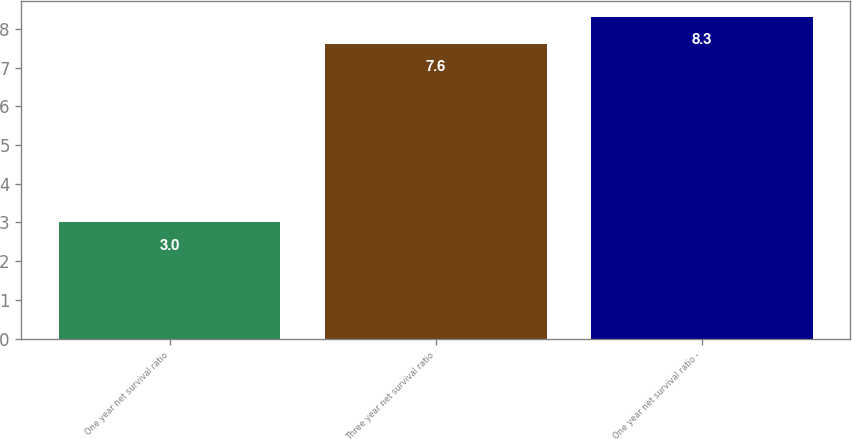Convert chart. <chart><loc_0><loc_0><loc_500><loc_500><bar_chart><fcel>One year net survival ratio<fcel>Three year net survival ratio<fcel>One year net survival ratio -<nl><fcel>3<fcel>7.6<fcel>8.3<nl></chart> 